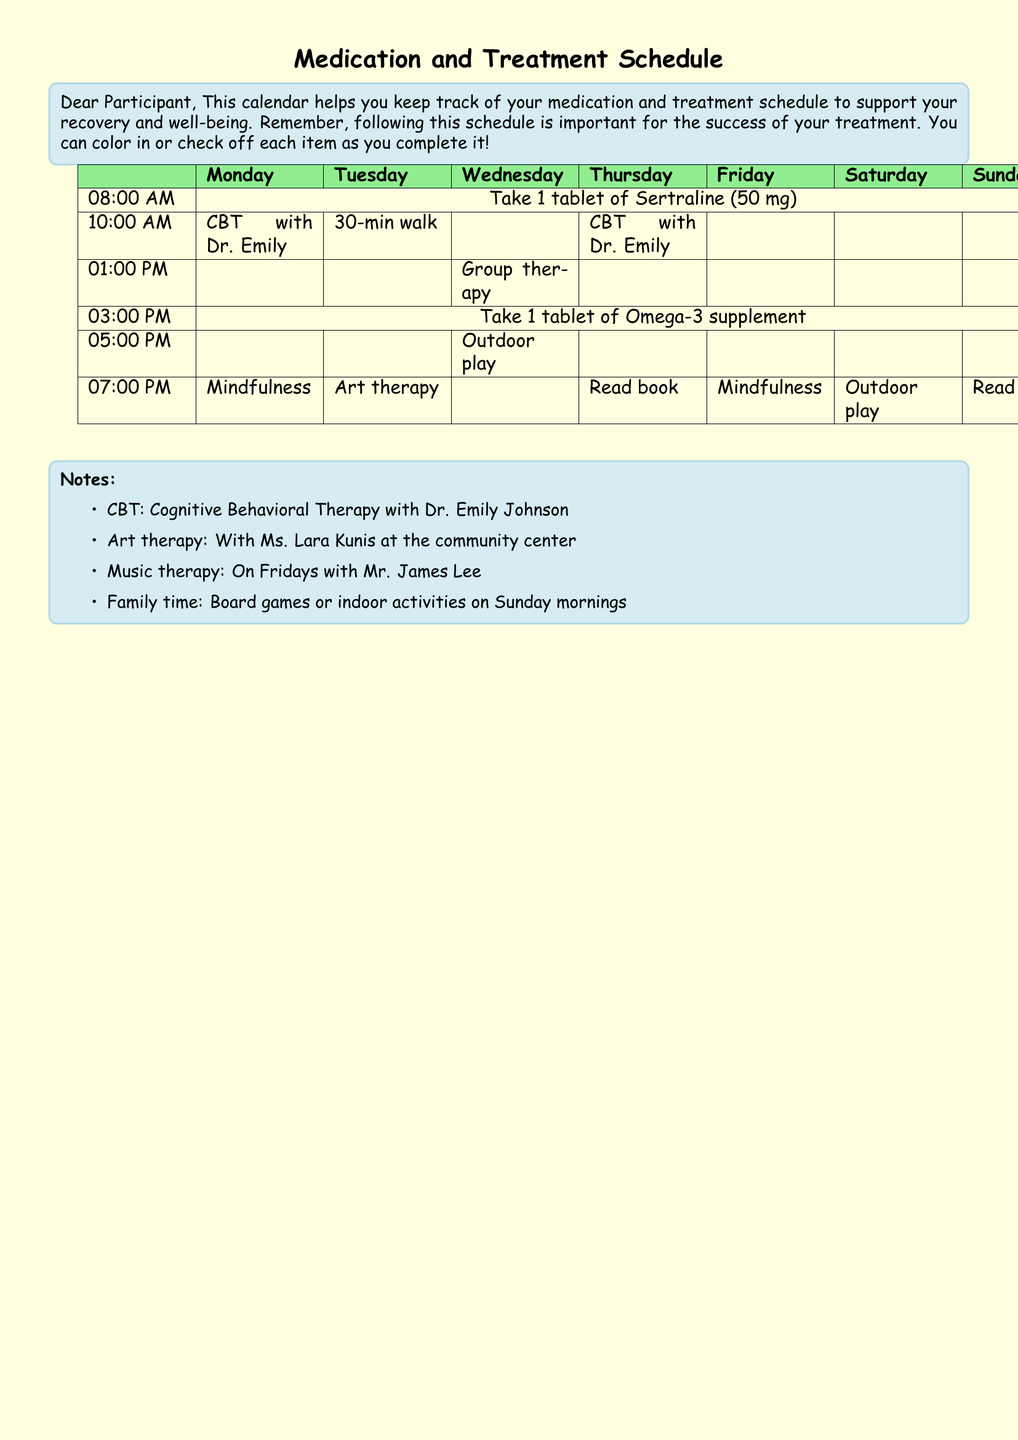What medication is taken at 8:00 AM? The document states to take 1 tablet of Sertraline (50 mg) at 8:00 AM.
Answer: Sertraline (50 mg) Who conducts the CBT sessions? The document mentions that CBT is conducted with Dr. Emily Johnson.
Answer: Dr. Emily Johnson Which activity is scheduled for Saturday at 5:00 PM? The document lists "Outdoor play" for Saturday at 5:00 PM.
Answer: Outdoor play What is the main purpose of this calendar? The introduction states that the calendar helps to keep track of medication and treatment schedule to support recovery and well-being.
Answer: Keep track of medication and treatment schedule How many times is "mindfulness" mentioned in the schedule? Mindfulness appears twice in the schedule, once on Monday and once on Friday at 7:00 PM.
Answer: 2 times What time does group therapy occur? The document states that group therapy occurs at 1:00 PM on Wednesday.
Answer: 1:00 PM What color is used for the title background? The background for the title section is light yellow.
Answer: Light yellow On what day is music therapy scheduled? The document indicates that music therapy is scheduled on Fridays.
Answer: Fridays What therapy involves Ms. Lara Kunis? According to the notes, art therapy is conducted with Ms. Lara Kunis.
Answer: Art therapy What is the session length for the walk on Tuesday? The document specifies that the walk on Tuesday lasts for 30 minutes.
Answer: 30 minutes 